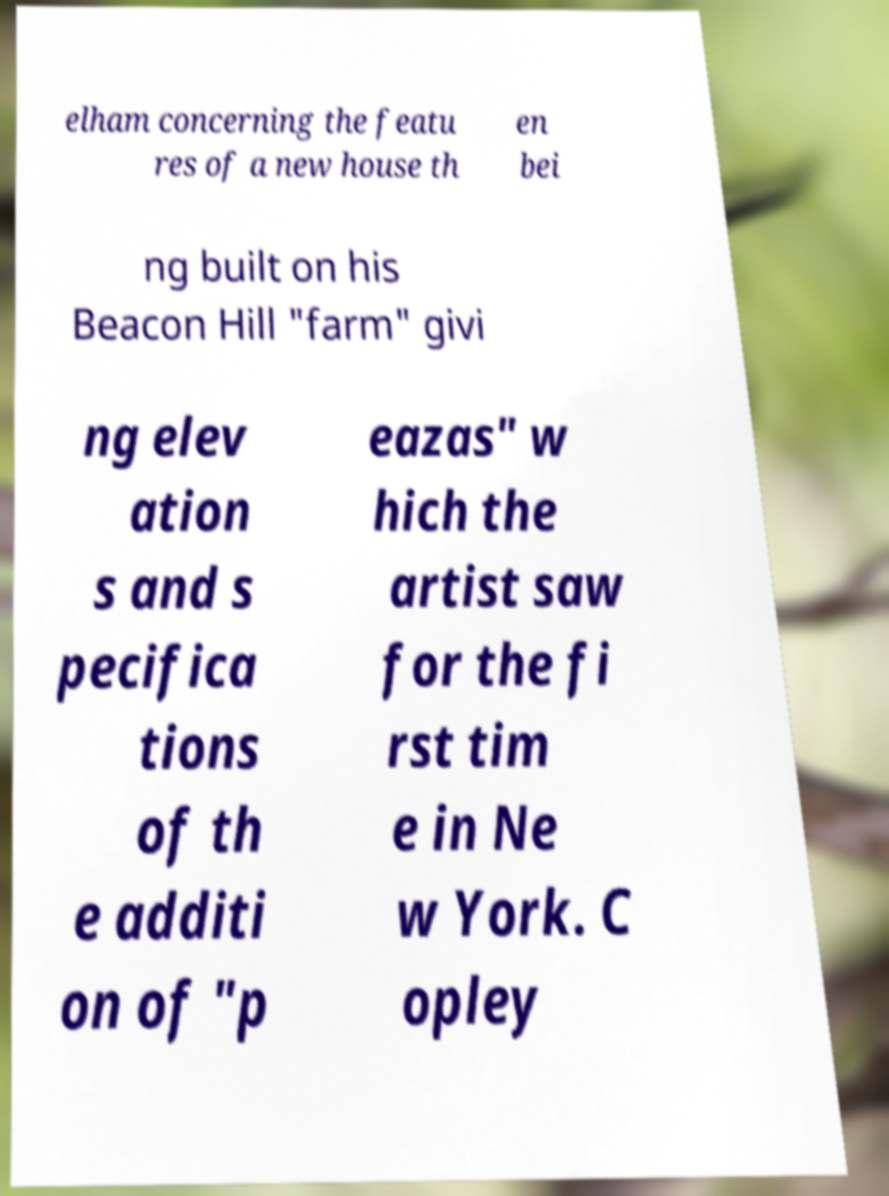For documentation purposes, I need the text within this image transcribed. Could you provide that? elham concerning the featu res of a new house th en bei ng built on his Beacon Hill "farm" givi ng elev ation s and s pecifica tions of th e additi on of "p eazas" w hich the artist saw for the fi rst tim e in Ne w York. C opley 